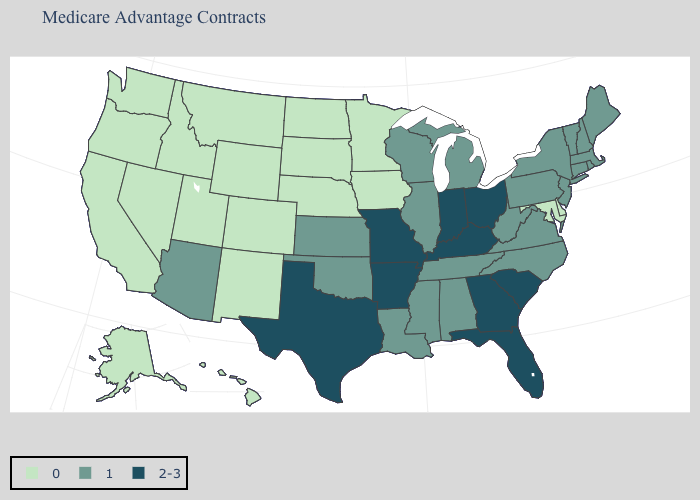What is the value of Maryland?
Give a very brief answer. 0. What is the value of Kansas?
Short answer required. 1. Is the legend a continuous bar?
Give a very brief answer. No. Name the states that have a value in the range 2-3?
Write a very short answer. Arkansas, Florida, Georgia, Indiana, Kentucky, Missouri, Ohio, South Carolina, Texas. Which states have the highest value in the USA?
Quick response, please. Arkansas, Florida, Georgia, Indiana, Kentucky, Missouri, Ohio, South Carolina, Texas. Does South Carolina have the highest value in the South?
Quick response, please. Yes. What is the value of Kansas?
Short answer required. 1. Name the states that have a value in the range 0?
Write a very short answer. Alaska, California, Colorado, Delaware, Hawaii, Iowa, Idaho, Maryland, Minnesota, Montana, North Dakota, Nebraska, New Mexico, Nevada, Oregon, South Dakota, Utah, Washington, Wyoming. Which states have the lowest value in the South?
Be succinct. Delaware, Maryland. What is the value of Oklahoma?
Quick response, please. 1. What is the value of Arkansas?
Short answer required. 2-3. Does the map have missing data?
Write a very short answer. No. Is the legend a continuous bar?
Short answer required. No. What is the highest value in states that border West Virginia?
Concise answer only. 2-3. Name the states that have a value in the range 1?
Concise answer only. Alabama, Arizona, Connecticut, Illinois, Kansas, Louisiana, Massachusetts, Maine, Michigan, Mississippi, North Carolina, New Hampshire, New Jersey, New York, Oklahoma, Pennsylvania, Rhode Island, Tennessee, Virginia, Vermont, Wisconsin, West Virginia. 